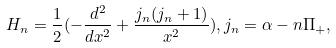<formula> <loc_0><loc_0><loc_500><loc_500>H _ { n } = \frac { 1 } { 2 } ( - \frac { d ^ { 2 } } { d x ^ { 2 } } + \frac { j _ { n } ( j _ { n } + 1 ) } { x ^ { 2 } } ) , j _ { n } = \alpha - n \Pi _ { + } ,</formula> 